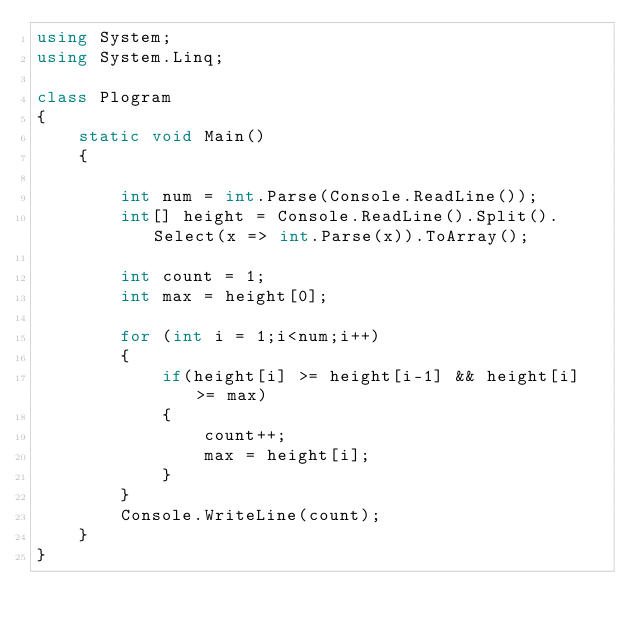Convert code to text. <code><loc_0><loc_0><loc_500><loc_500><_C#_>using System;
using System.Linq;

class Plogram
{
    static void Main()
    {

        int num = int.Parse(Console.ReadLine());
        int[] height = Console.ReadLine().Split().Select(x => int.Parse(x)).ToArray();

        int count = 1;
        int max = height[0];

        for (int i = 1;i<num;i++)
        {
            if(height[i] >= height[i-1] && height[i] >= max)
            {
                count++;
                max = height[i];
            }
        }
        Console.WriteLine(count);
    }
}</code> 